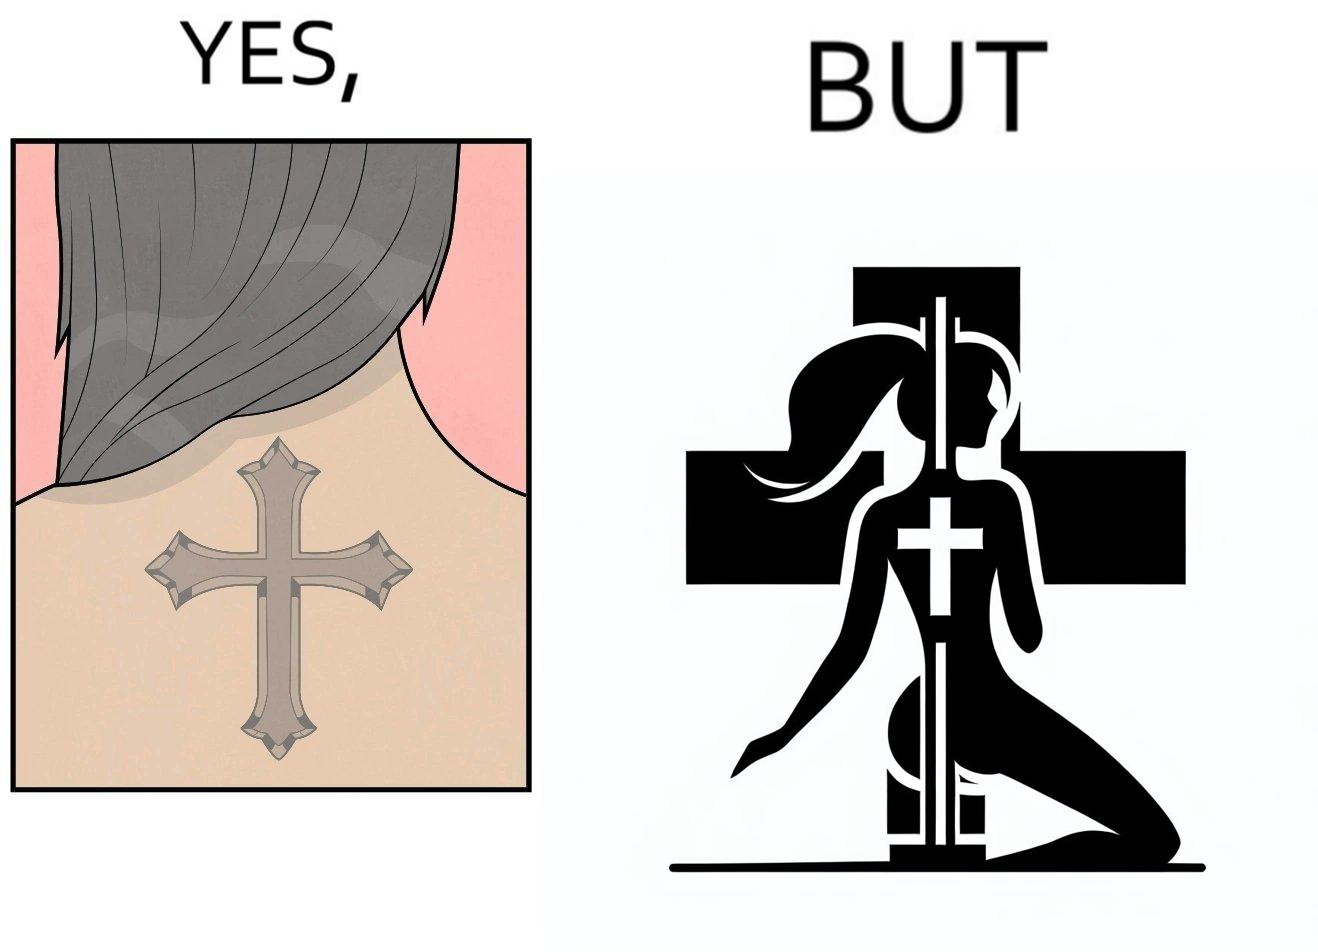Does this image contain satire or humor? Yes, this image is satirical. 